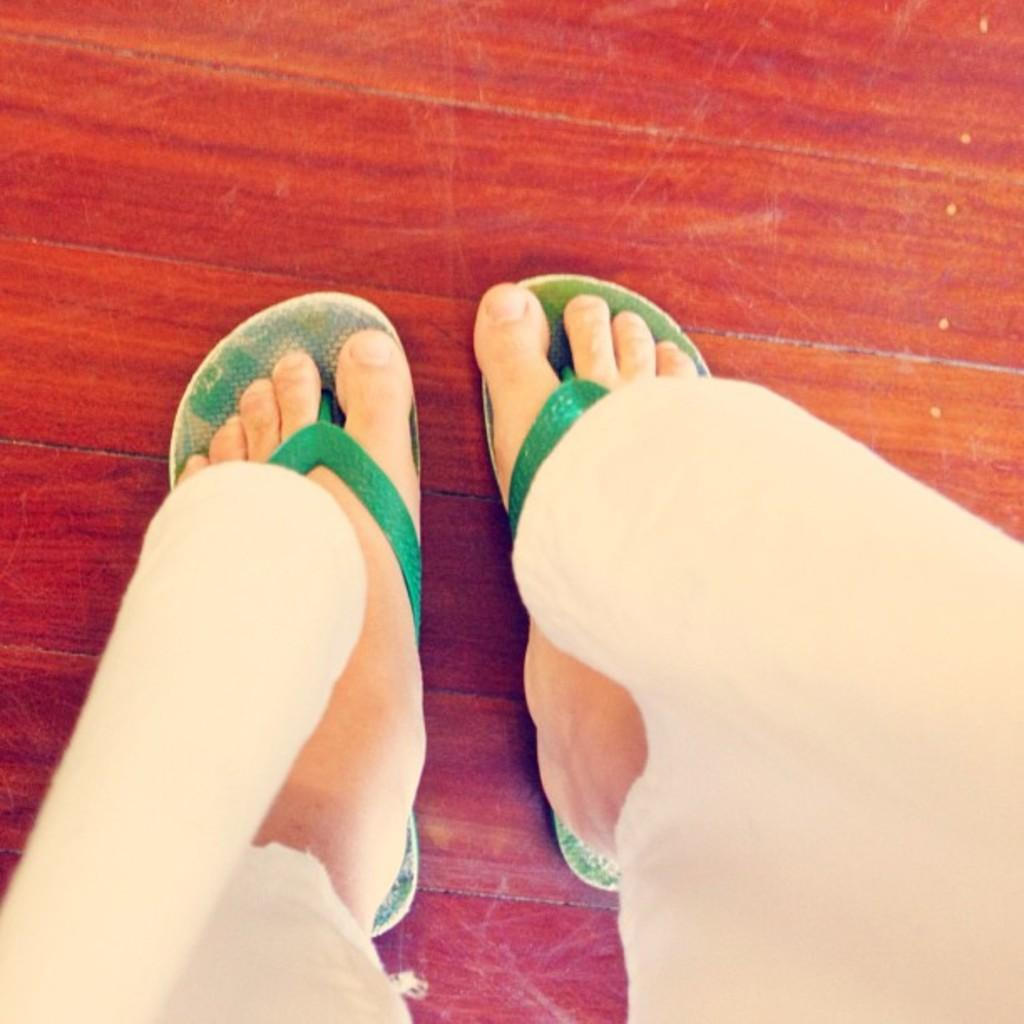What part of a person can be seen in the image? There are legs of a person in the image. What type of footwear is the person wearing? The person is wearing footwear. What material is the surface that the person's legs are on? There is a wooden surface in the image. How does the person use the wooden surface to crush the object in the image? There is no object present in the image to be crushed, and the person is not using the wooden surface to crush anything. 